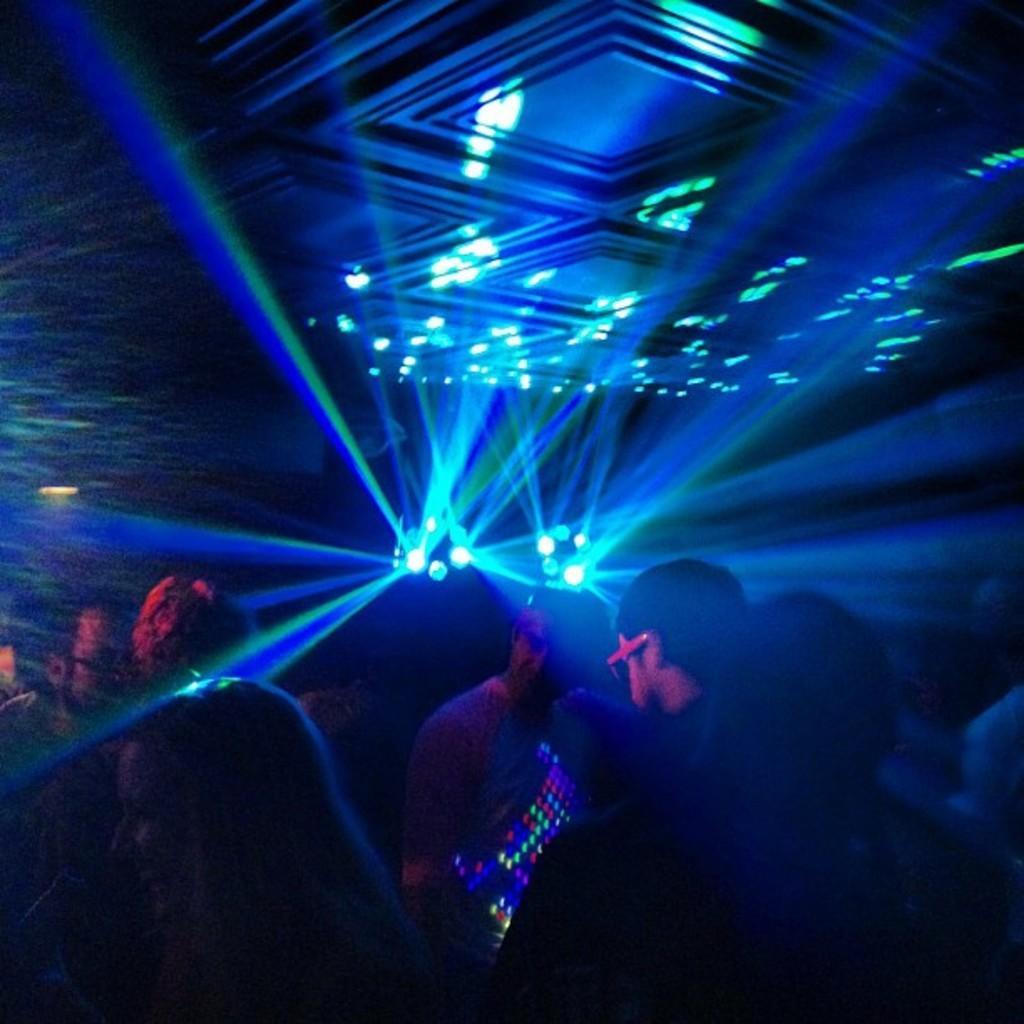In one or two sentences, can you explain what this image depicts? In this picture I see number of people in front and in the background I see the blue color lights and I see that it is a bit dark. 